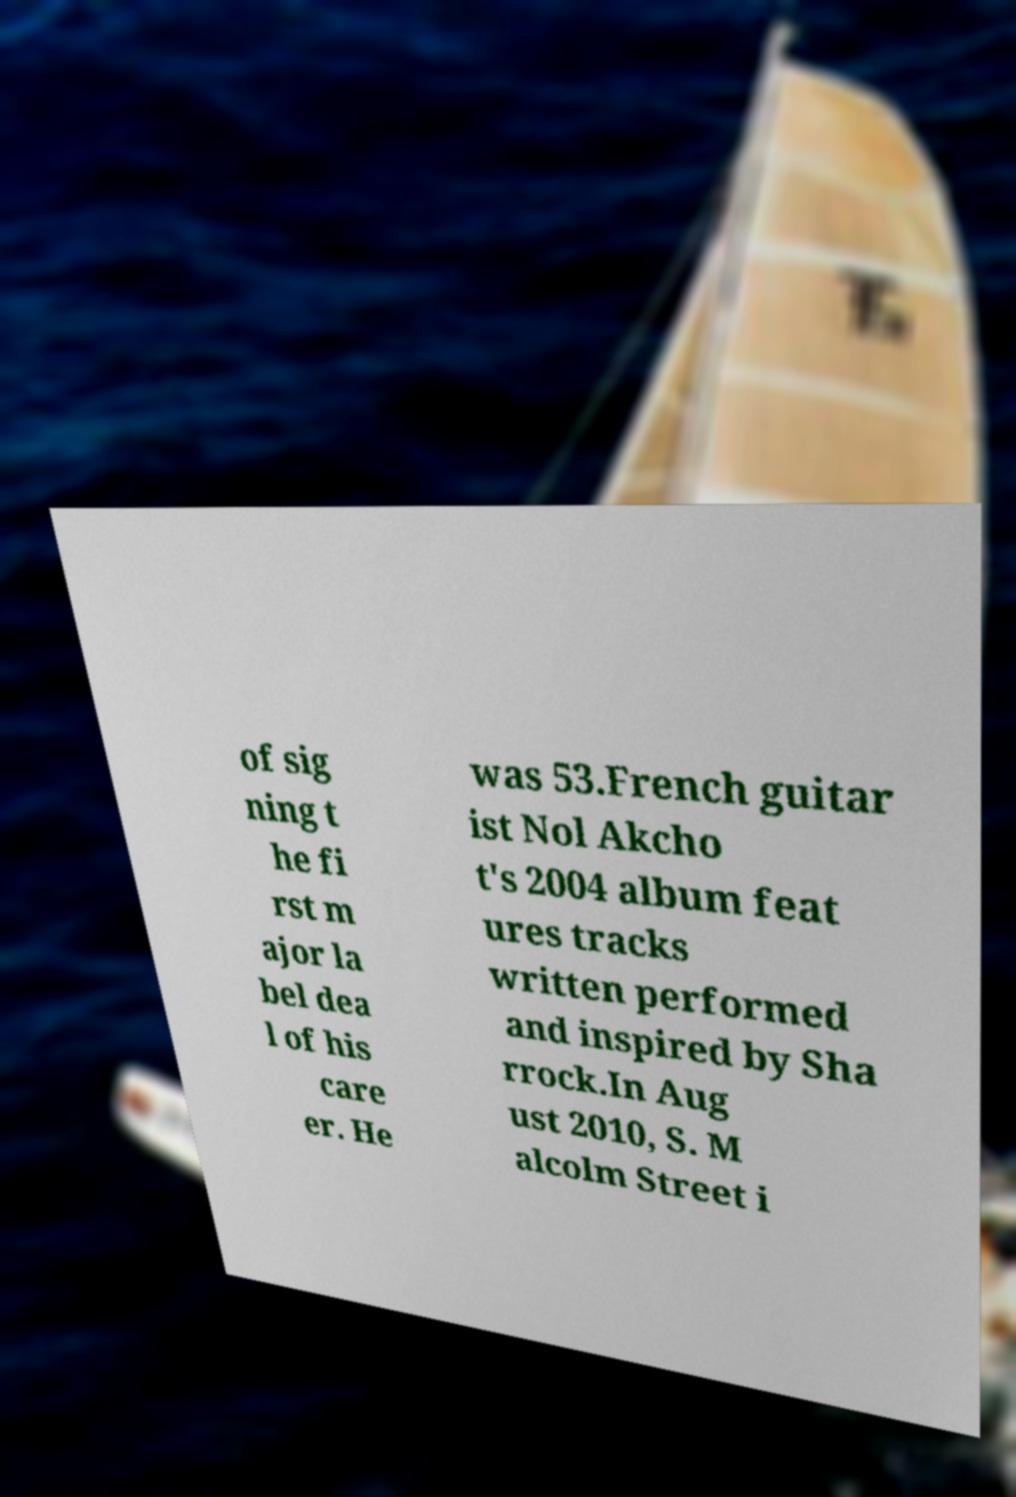Please identify and transcribe the text found in this image. of sig ning t he fi rst m ajor la bel dea l of his care er. He was 53.French guitar ist Nol Akcho t's 2004 album feat ures tracks written performed and inspired by Sha rrock.In Aug ust 2010, S. M alcolm Street i 